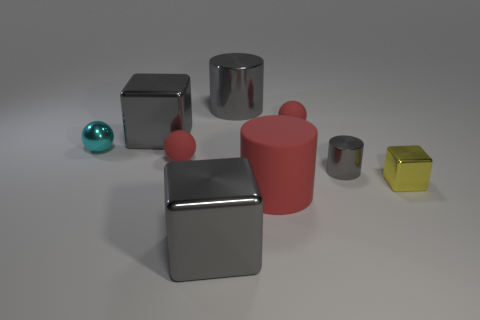There is a big cylinder that is the same color as the small cylinder; what material is it?
Offer a terse response. Metal. What number of things are either matte balls or red rubber things?
Your answer should be compact. 3. There is a yellow cube; is its size the same as the metallic cylinder that is on the right side of the big rubber thing?
Offer a terse response. Yes. What number of other things are made of the same material as the small cyan ball?
Give a very brief answer. 5. How many objects are gray metal blocks that are in front of the tiny cyan sphere or big things that are behind the cyan metallic ball?
Make the answer very short. 3. There is a large red object that is the same shape as the small gray object; what is its material?
Ensure brevity in your answer.  Rubber. Are there any large purple matte balls?
Provide a succinct answer. No. There is a cylinder that is both left of the tiny cylinder and behind the tiny block; what size is it?
Your answer should be very brief. Large. What is the shape of the tiny yellow shiny object?
Offer a very short reply. Cube. Is there a sphere left of the gray metal cylinder that is behind the cyan metal ball?
Ensure brevity in your answer.  Yes. 